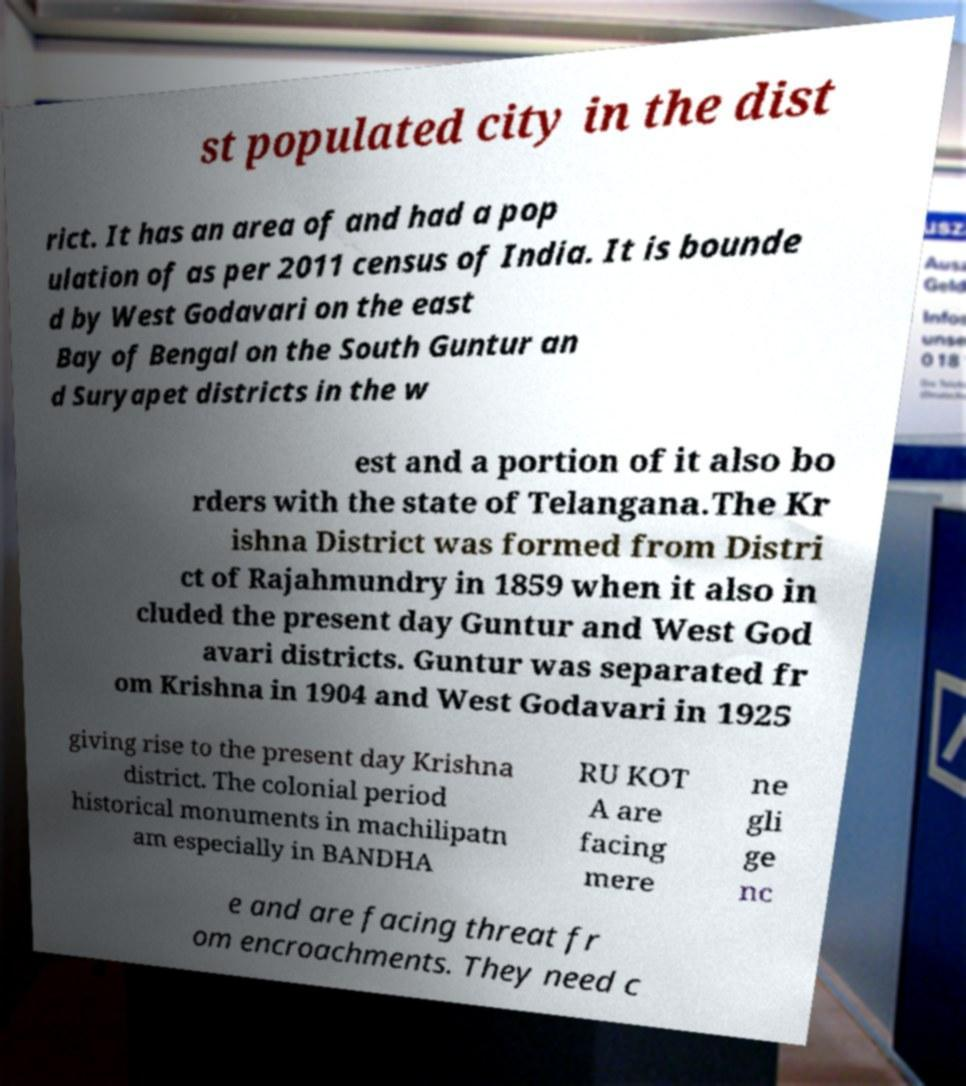Can you read and provide the text displayed in the image?This photo seems to have some interesting text. Can you extract and type it out for me? st populated city in the dist rict. It has an area of and had a pop ulation of as per 2011 census of India. It is bounde d by West Godavari on the east Bay of Bengal on the South Guntur an d Suryapet districts in the w est and a portion of it also bo rders with the state of Telangana.The Kr ishna District was formed from Distri ct of Rajahmundry in 1859 when it also in cluded the present day Guntur and West God avari districts. Guntur was separated fr om Krishna in 1904 and West Godavari in 1925 giving rise to the present day Krishna district. The colonial period historical monuments in machilipatn am especially in BANDHA RU KOT A are facing mere ne gli ge nc e and are facing threat fr om encroachments. They need c 